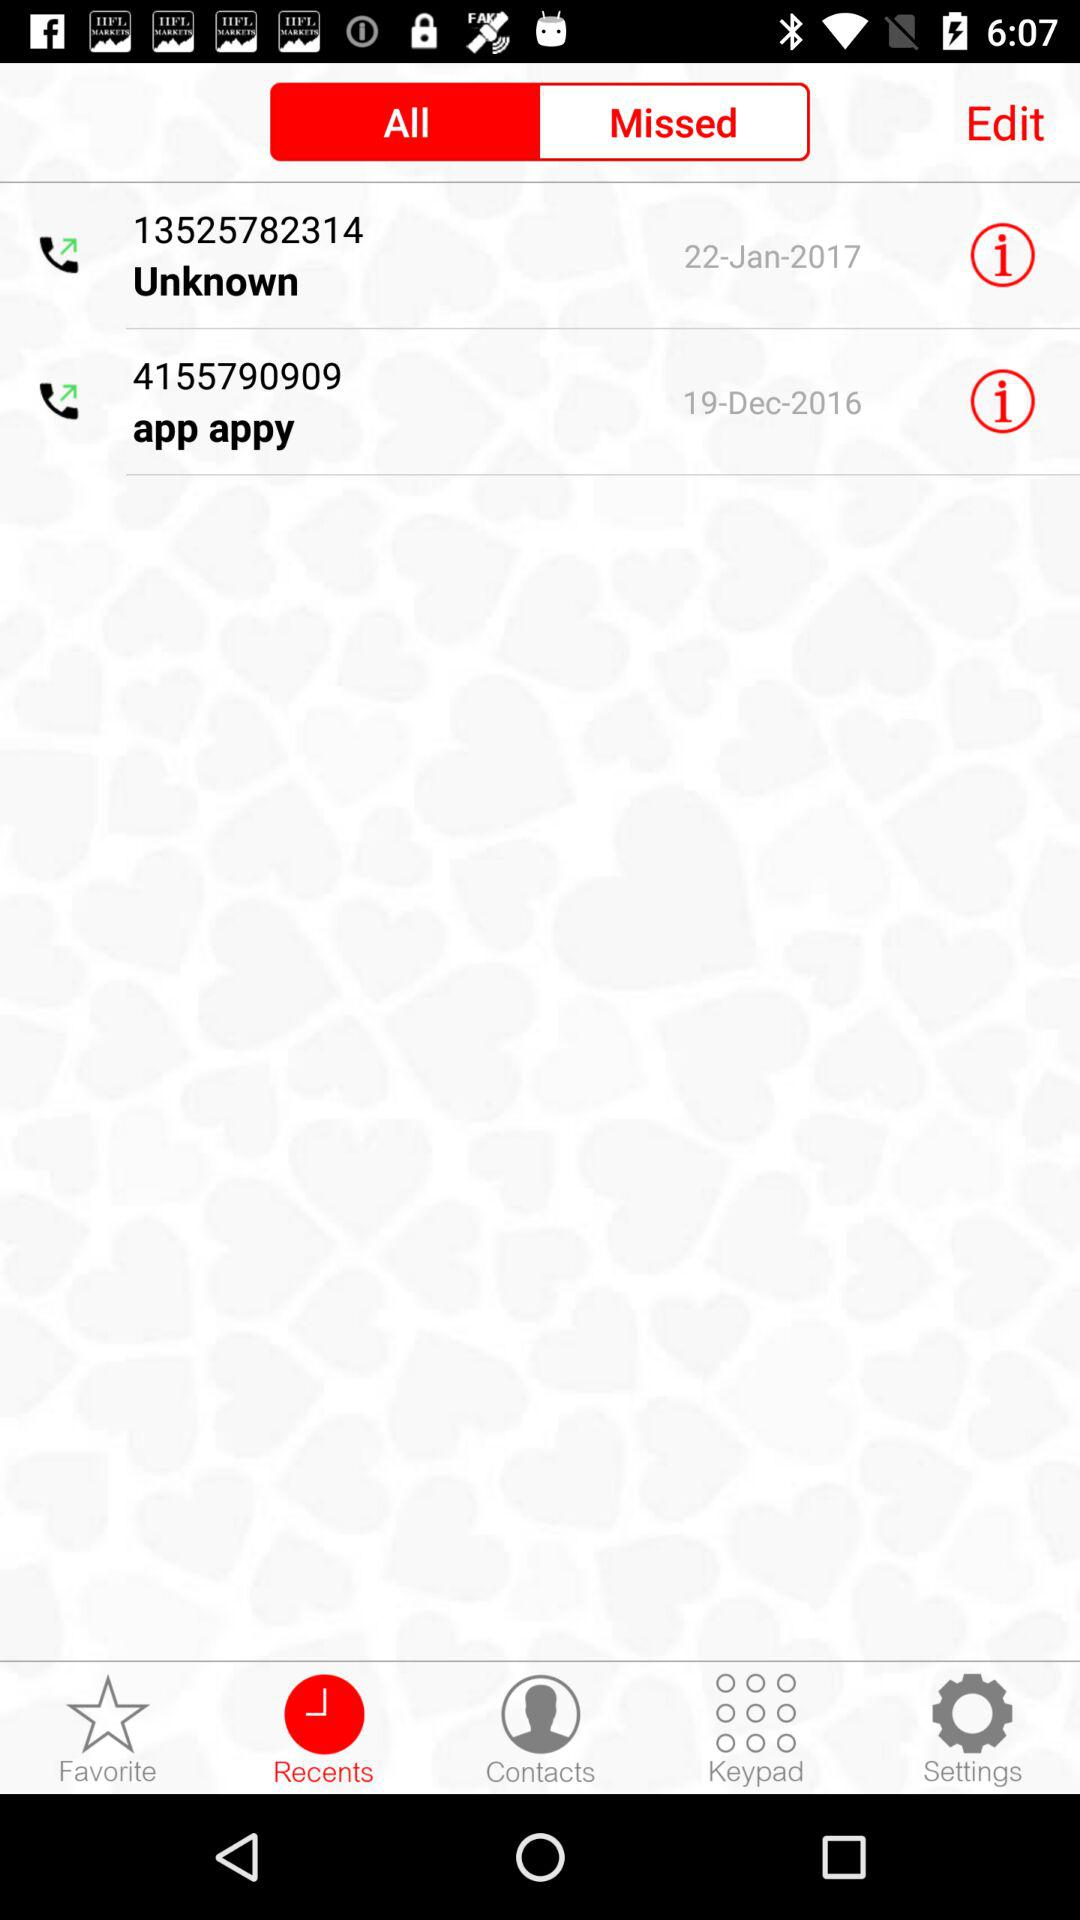What is the selected tab? The selected tabs are "Recents" and "All". 